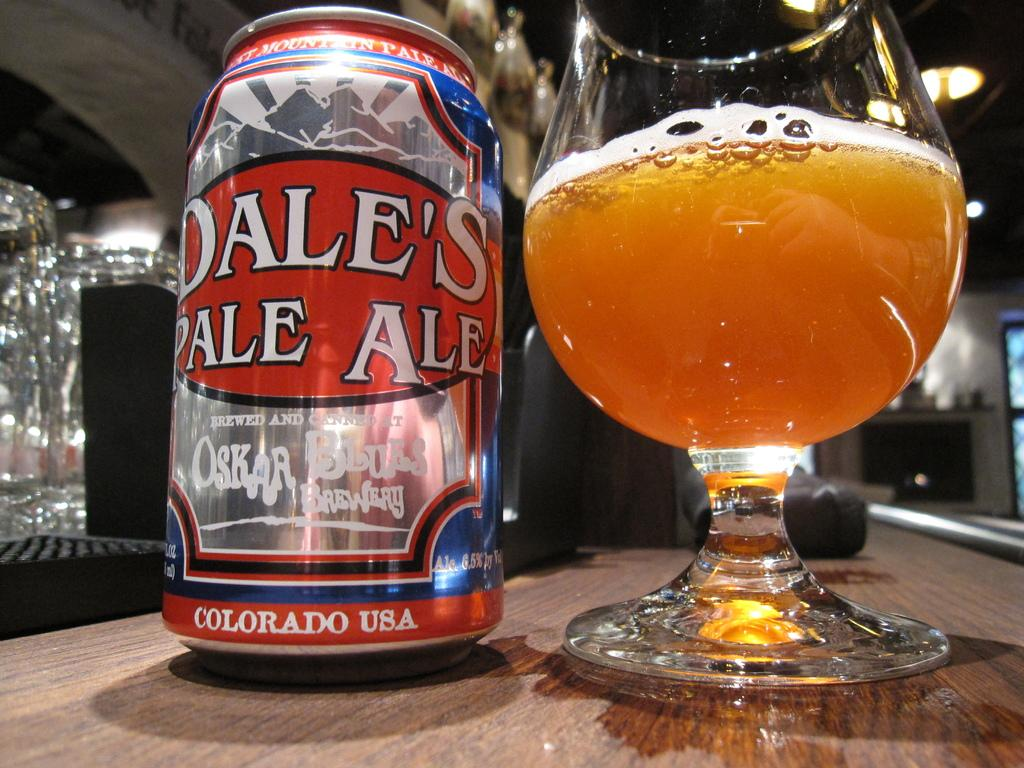<image>
Describe the image concisely. A glass of Dale's Pale Ale sits next to the can it came in. 